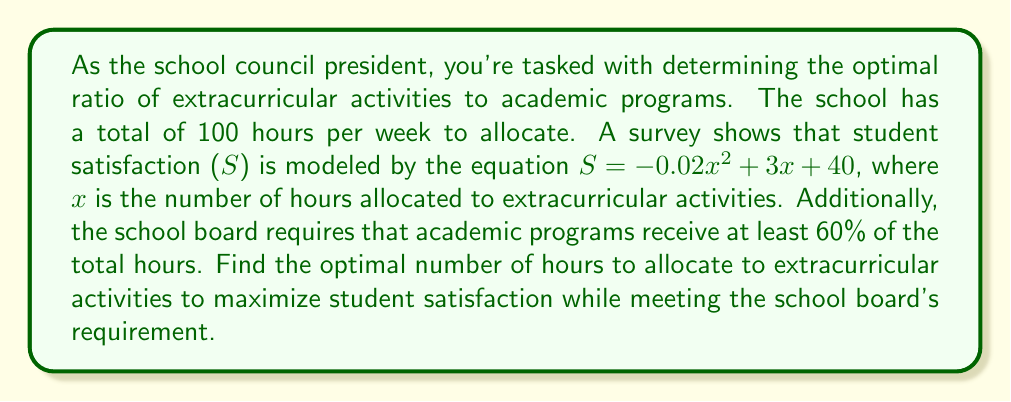Can you answer this question? 1) Let's define our variables:
   $x$ = hours for extracurricular activities
   $y$ = hours for academic programs

2) We know the total hours is 100, so:
   $x + y = 100$

3) The school board requires academic programs to receive at least 60% of total hours:
   $y \geq 0.6(100) = 60$

4) Combining (2) and (3):
   $100 - x \geq 60$
   $40 \geq x$

5) The student satisfaction function is:
   $S = -0.02x^2 + 3x + 40$

6) To find the maximum of this quadratic function, we find where its derivative equals zero:
   $\frac{dS}{dx} = -0.04x + 3 = 0$
   $0.04x = 3$
   $x = 75$

7) However, $x = 75$ doesn't satisfy our constraint $x \leq 40$ from step 4.

8) Since the parabola opens downward and the unconstrained maximum is beyond our feasible region, the maximum within our constraints will occur at the boundary: $x = 40$.

9) Verify the satisfaction at $x = 40$:
   $S = -0.02(40)^2 + 3(40) + 40 = -32 + 120 + 40 = 128$

Therefore, the optimal allocation is 40 hours for extracurricular activities and 60 hours for academic programs.
Answer: 40 hours for extracurricular activities 